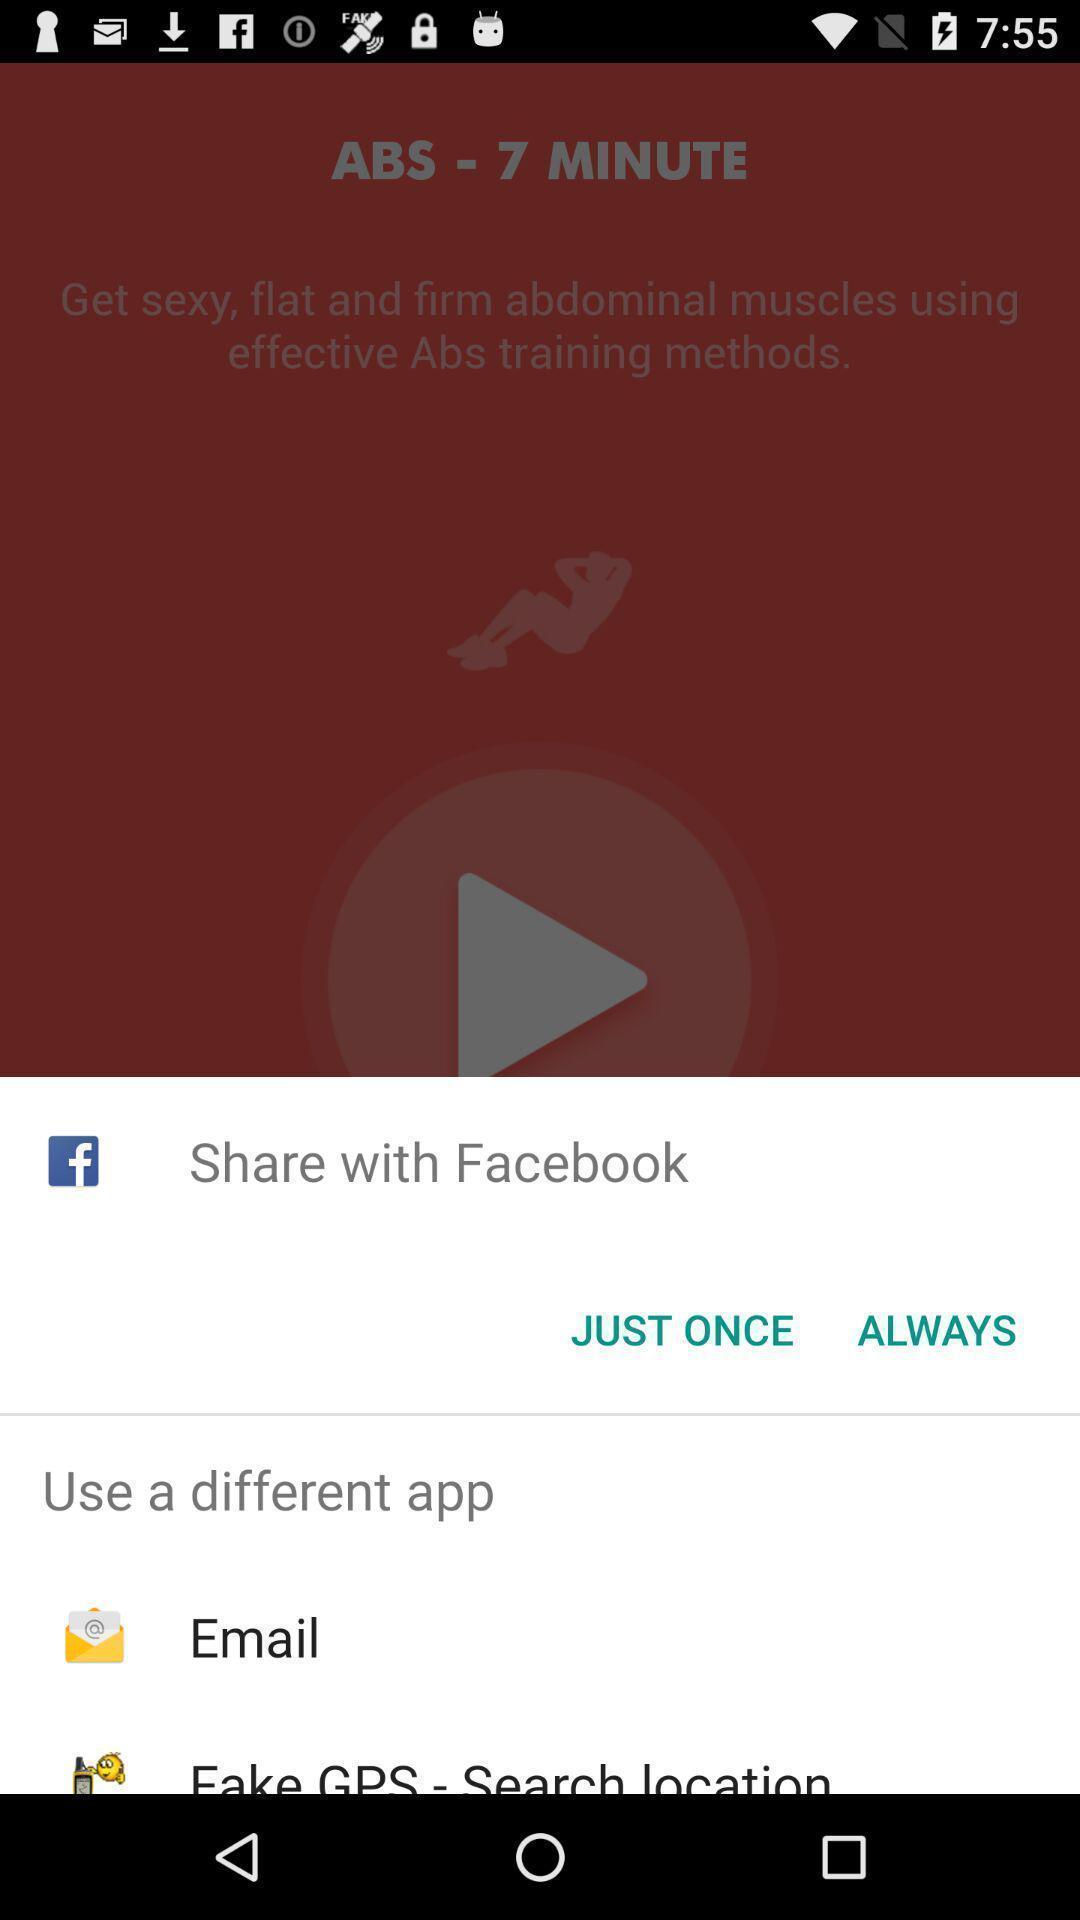Describe the content in this image. Pop-up showing various options to share. 